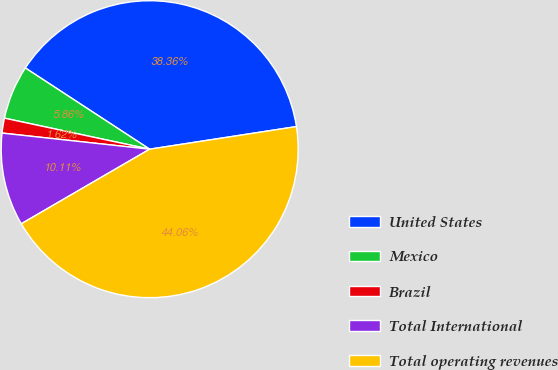<chart> <loc_0><loc_0><loc_500><loc_500><pie_chart><fcel>United States<fcel>Mexico<fcel>Brazil<fcel>Total International<fcel>Total operating revenues<nl><fcel>38.36%<fcel>5.86%<fcel>1.62%<fcel>10.11%<fcel>44.06%<nl></chart> 